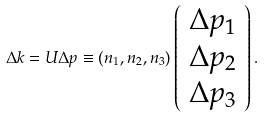Convert formula to latex. <formula><loc_0><loc_0><loc_500><loc_500>\Delta k = U \Delta p \equiv \left ( n _ { 1 } , n _ { 2 } , n _ { 3 } \right ) \left ( \begin{array} { c } \Delta p _ { 1 } \\ \Delta p _ { 2 } \\ \Delta p _ { 3 } \end{array} \right ) .</formula> 